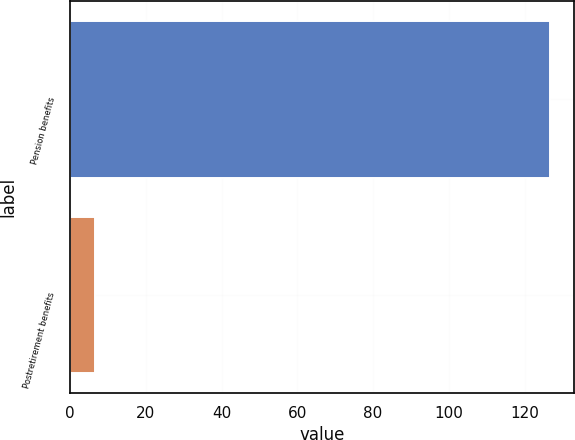Convert chart. <chart><loc_0><loc_0><loc_500><loc_500><bar_chart><fcel>Pension benefits<fcel>Postretirement benefits<nl><fcel>126.8<fcel>6.5<nl></chart> 